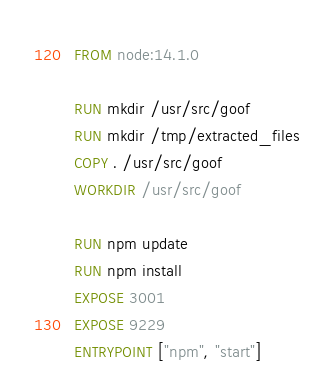Convert code to text. <code><loc_0><loc_0><loc_500><loc_500><_Dockerfile_>FROM node:14.1.0

RUN mkdir /usr/src/goof
RUN mkdir /tmp/extracted_files
COPY . /usr/src/goof
WORKDIR /usr/src/goof

RUN npm update
RUN npm install
EXPOSE 3001
EXPOSE 9229
ENTRYPOINT ["npm", "start"]
</code> 